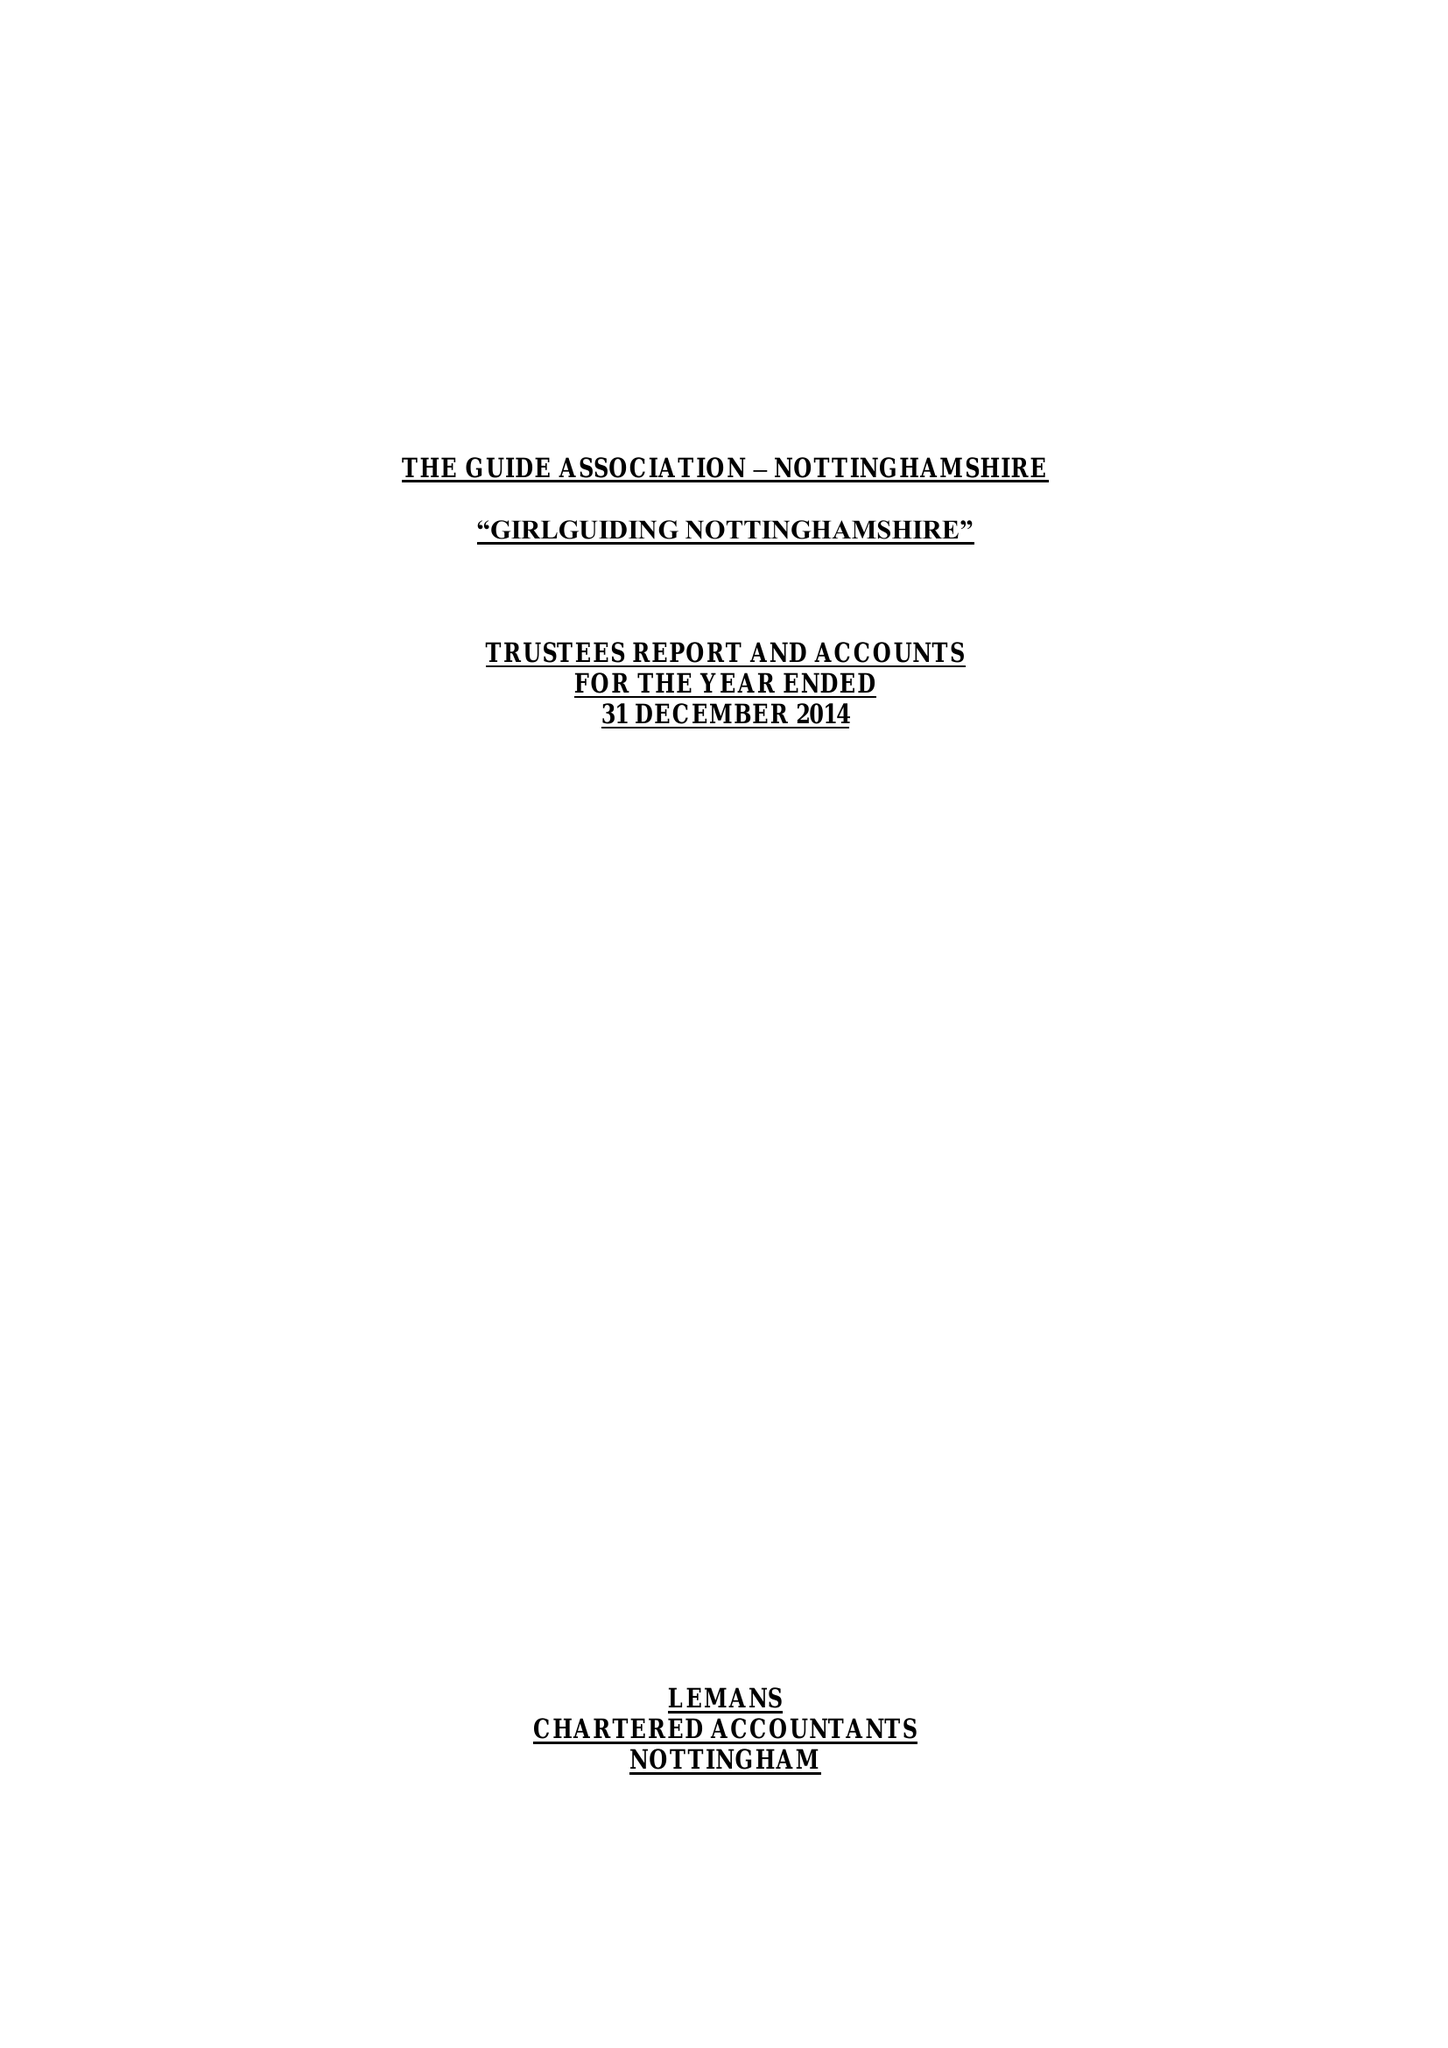What is the value for the address__postcode?
Answer the question using a single word or phrase. NG4 3DF 